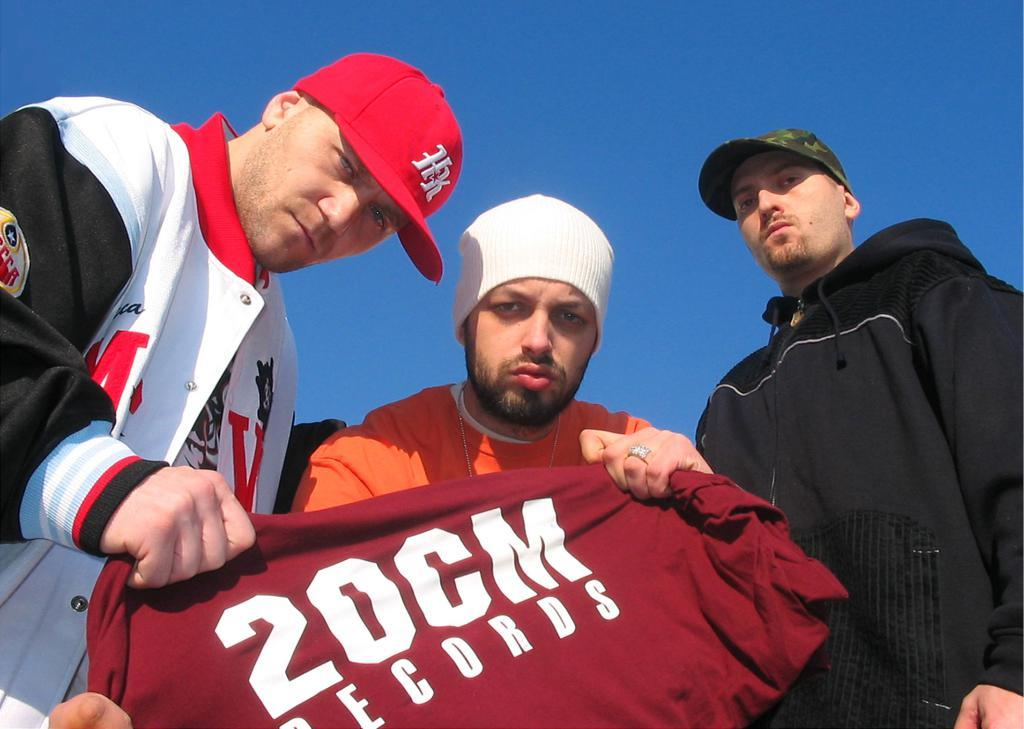<image>
Write a terse but informative summary of the picture. some people holding a shirt that says 20 cm on it 